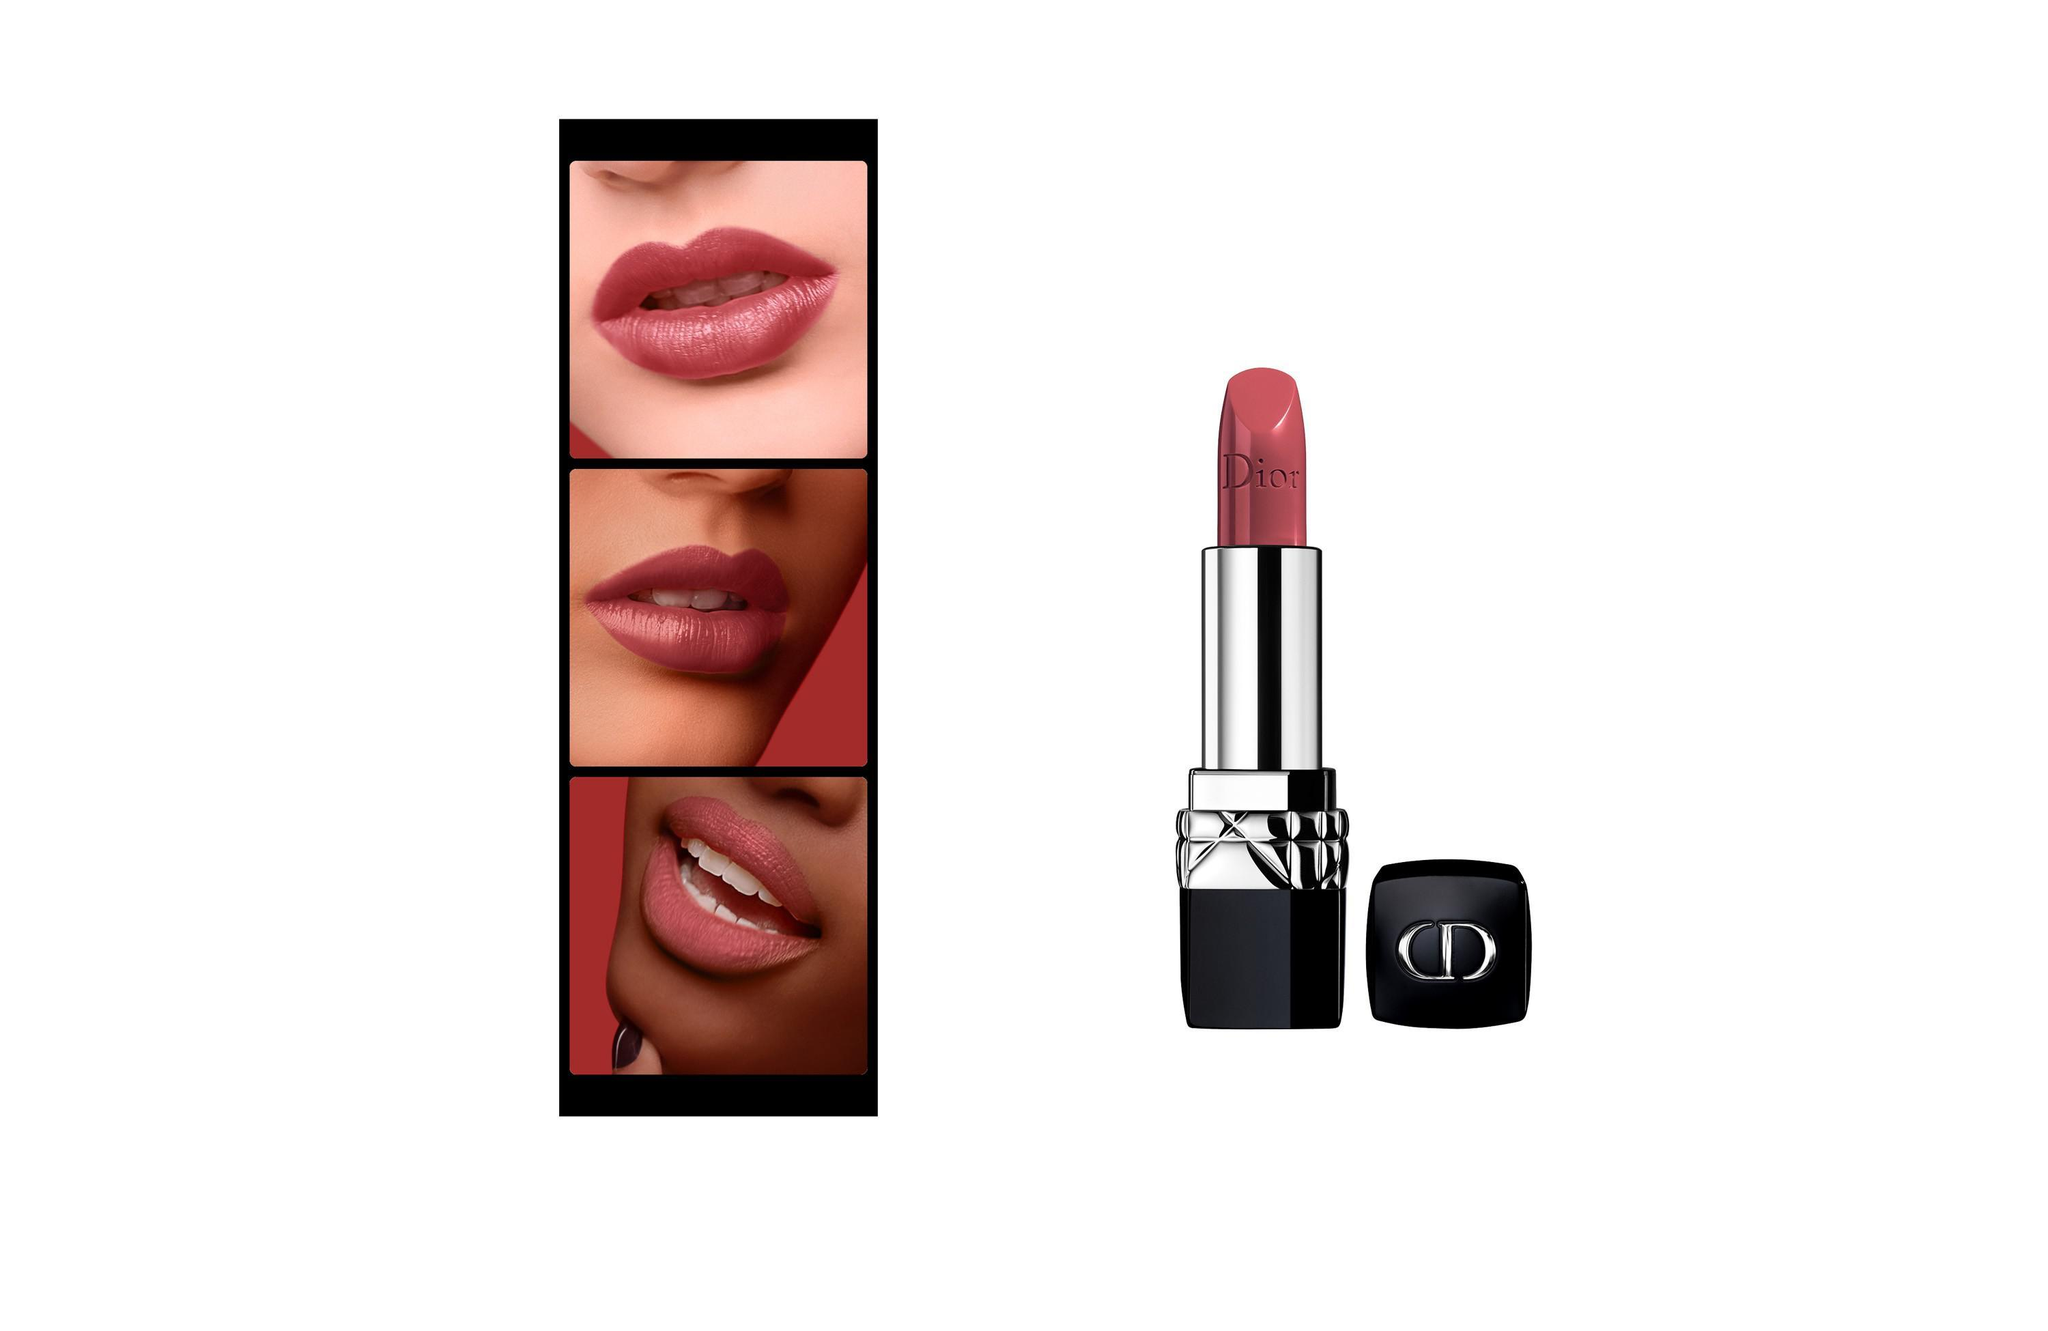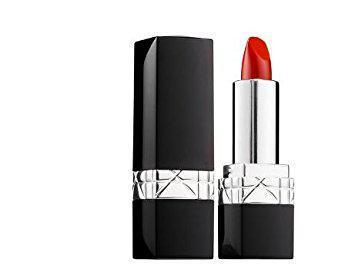The first image is the image on the left, the second image is the image on the right. For the images shown, is this caption "A red lipstick in one image is in a silver holder with black base, with a matching black cap with silver band sitting upright and level beside it." true? Answer yes or no. Yes. The first image is the image on the left, the second image is the image on the right. For the images shown, is this caption "A red lipstick in a silver tube is displayed level to and alongside of its upright black cap." true? Answer yes or no. Yes. 